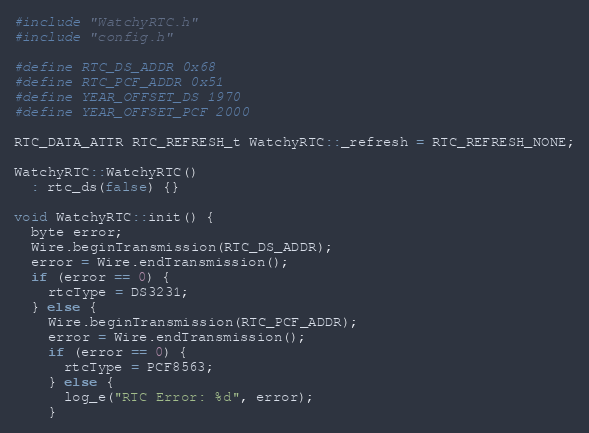Convert code to text. <code><loc_0><loc_0><loc_500><loc_500><_C++_>#include "WatchyRTC.h"
#include "config.h"

#define RTC_DS_ADDR 0x68
#define RTC_PCF_ADDR 0x51
#define YEAR_OFFSET_DS 1970
#define YEAR_OFFSET_PCF 2000

RTC_DATA_ATTR RTC_REFRESH_t WatchyRTC::_refresh = RTC_REFRESH_NONE;

WatchyRTC::WatchyRTC() 
  : rtc_ds(false) {}

void WatchyRTC::init() {
  byte error;
  Wire.beginTransmission(RTC_DS_ADDR);
  error = Wire.endTransmission();
  if (error == 0) {
    rtcType = DS3231;
  } else {
    Wire.beginTransmission(RTC_PCF_ADDR);
    error = Wire.endTransmission();
    if (error == 0) {
      rtcType = PCF8563;
    } else {
      log_e("RTC Error: %d", error);
    }</code> 